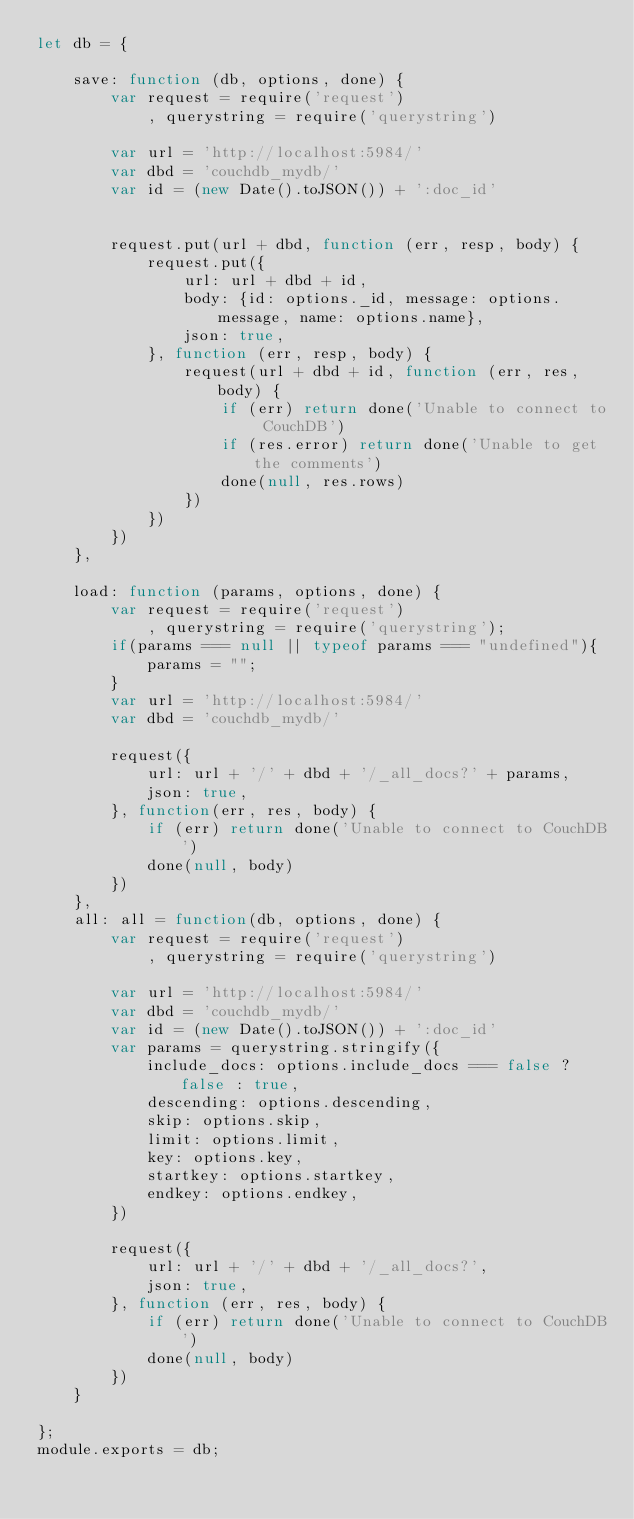<code> <loc_0><loc_0><loc_500><loc_500><_JavaScript_>let db = {

    save: function (db, options, done) {
        var request = require('request')
            , querystring = require('querystring')

        var url = 'http://localhost:5984/'
        var dbd = 'couchdb_mydb/'
        var id = (new Date().toJSON()) + ':doc_id'


        request.put(url + dbd, function (err, resp, body) {
            request.put({
                url: url + dbd + id,
                body: {id: options._id, message: options.message, name: options.name},
                json: true,
            }, function (err, resp, body) {
                request(url + dbd + id, function (err, res, body) {
                    if (err) return done('Unable to connect to CouchDB')
                    if (res.error) return done('Unable to get the comments')
                    done(null, res.rows)
                })
            })
        })
    },

    load: function (params, options, done) {
        var request = require('request')
            , querystring = require('querystring');
        if(params === null || typeof params === "undefined"){
            params = "";
        }
        var url = 'http://localhost:5984/'
        var dbd = 'couchdb_mydb/'

        request({
            url: url + '/' + dbd + '/_all_docs?' + params,
            json: true,
        }, function(err, res, body) {
            if (err) return done('Unable to connect to CouchDB')
            done(null, body)
        })
    },
    all: all = function(db, options, done) {
        var request = require('request')
            , querystring = require('querystring')

        var url = 'http://localhost:5984/'
        var dbd = 'couchdb_mydb/'
        var id = (new Date().toJSON()) + ':doc_id'
        var params = querystring.stringify({
            include_docs: options.include_docs === false ? false : true,
            descending: options.descending,
            skip: options.skip,
            limit: options.limit,
            key: options.key,
            startkey: options.startkey,
            endkey: options.endkey,
        })

        request({
            url: url + '/' + dbd + '/_all_docs?',
            json: true,
        }, function (err, res, body) {
            if (err) return done('Unable to connect to CouchDB')
            done(null, body)
        })
    }

};
module.exports = db;</code> 